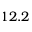<formula> <loc_0><loc_0><loc_500><loc_500>1 2 . 2</formula> 